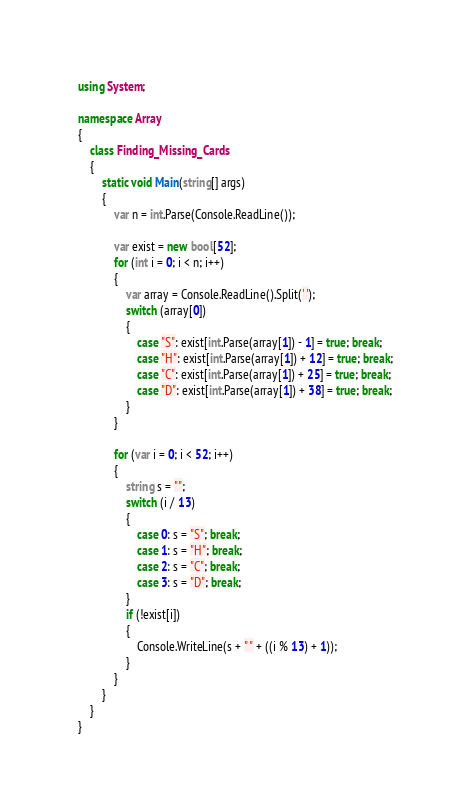Convert code to text. <code><loc_0><loc_0><loc_500><loc_500><_C#_>using System;

namespace Array
{
    class Finding_Missing_Cards
    {
        static void Main(string[] args)
        {
            var n = int.Parse(Console.ReadLine());

            var exist = new bool[52];
            for (int i = 0; i < n; i++)
            {
                var array = Console.ReadLine().Split(' ');
                switch (array[0])
                {
                    case "S": exist[int.Parse(array[1]) - 1] = true; break;
                    case "H": exist[int.Parse(array[1]) + 12] = true; break;
                    case "C": exist[int.Parse(array[1]) + 25] = true; break;
                    case "D": exist[int.Parse(array[1]) + 38] = true; break;
                }
            }

            for (var i = 0; i < 52; i++)
            {
                string s = "";
                switch (i / 13)
                {
                    case 0: s = "S"; break;
                    case 1: s = "H"; break;
                    case 2: s = "C"; break;
                    case 3: s = "D"; break;
                }
                if (!exist[i])
                {
                    Console.WriteLine(s + " " + ((i % 13) + 1));
                }
            }
        }
    }
}</code> 